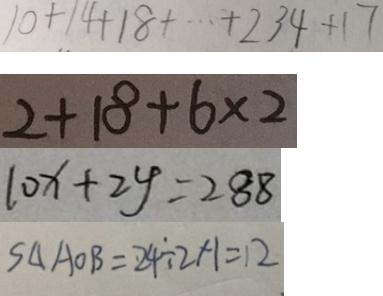<formula> <loc_0><loc_0><loc_500><loc_500>1 0 + 1 4 + 1 8 + \cdots + 2 3 4 + 1 7 
 2 + 1 8 + 6 \times 2 
 1 0 x + 2 y = 2 8 8 
 S _ { \Delta } A O B = 2 4 \div 2 \times 1 = 1 2</formula> 